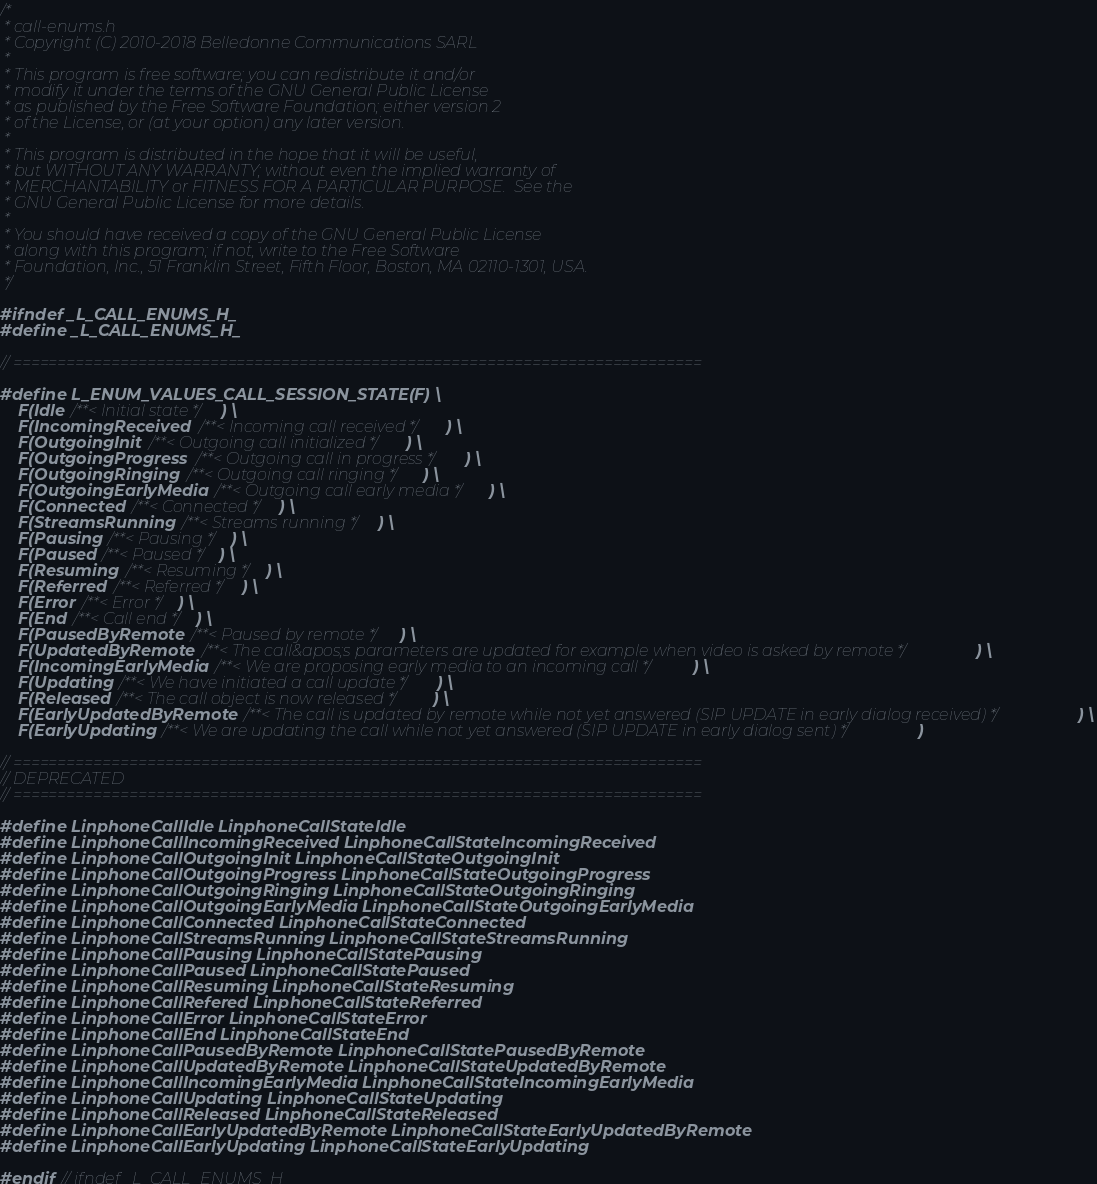Convert code to text. <code><loc_0><loc_0><loc_500><loc_500><_C_>/*
 * call-enums.h
 * Copyright (C) 2010-2018 Belledonne Communications SARL
 *
 * This program is free software; you can redistribute it and/or
 * modify it under the terms of the GNU General Public License
 * as published by the Free Software Foundation; either version 2
 * of the License, or (at your option) any later version.
 *
 * This program is distributed in the hope that it will be useful,
 * but WITHOUT ANY WARRANTY; without even the implied warranty of
 * MERCHANTABILITY or FITNESS FOR A PARTICULAR PURPOSE.  See the
 * GNU General Public License for more details.
 *
 * You should have received a copy of the GNU General Public License
 * along with this program; if not, write to the Free Software
 * Foundation, Inc., 51 Franklin Street, Fifth Floor, Boston, MA 02110-1301, USA.
 */

#ifndef _L_CALL_ENUMS_H_
#define _L_CALL_ENUMS_H_

// =============================================================================

#define L_ENUM_VALUES_CALL_SESSION_STATE(F) \
	F(Idle /**< Initial state */) \
	F(IncomingReceived /**< Incoming call received */) \
	F(OutgoingInit /**< Outgoing call initialized */) \
	F(OutgoingProgress /**< Outgoing call in progress */) \
	F(OutgoingRinging /**< Outgoing call ringing */) \
	F(OutgoingEarlyMedia /**< Outgoing call early media */) \
	F(Connected /**< Connected */) \
	F(StreamsRunning /**< Streams running */) \
	F(Pausing /**< Pausing */) \
	F(Paused /**< Paused */) \
	F(Resuming /**< Resuming */) \
	F(Referred /**< Referred */) \
	F(Error /**< Error */) \
	F(End /**< Call end */) \
	F(PausedByRemote /**< Paused by remote */) \
	F(UpdatedByRemote /**< The call&apos;s parameters are updated for example when video is asked by remote */) \
	F(IncomingEarlyMedia /**< We are proposing early media to an incoming call */) \
	F(Updating /**< We have initiated a call update */) \
	F(Released /**< The call object is now released */) \
	F(EarlyUpdatedByRemote /**< The call is updated by remote while not yet answered (SIP UPDATE in early dialog received) */) \
	F(EarlyUpdating /**< We are updating the call while not yet answered (SIP UPDATE in early dialog sent) */)

// =============================================================================
// DEPRECATED
// =============================================================================

#define LinphoneCallIdle LinphoneCallStateIdle
#define LinphoneCallIncomingReceived LinphoneCallStateIncomingReceived
#define LinphoneCallOutgoingInit LinphoneCallStateOutgoingInit
#define LinphoneCallOutgoingProgress LinphoneCallStateOutgoingProgress
#define LinphoneCallOutgoingRinging LinphoneCallStateOutgoingRinging
#define LinphoneCallOutgoingEarlyMedia LinphoneCallStateOutgoingEarlyMedia
#define LinphoneCallConnected LinphoneCallStateConnected
#define LinphoneCallStreamsRunning LinphoneCallStateStreamsRunning
#define LinphoneCallPausing LinphoneCallStatePausing
#define LinphoneCallPaused LinphoneCallStatePaused
#define LinphoneCallResuming LinphoneCallStateResuming
#define LinphoneCallRefered LinphoneCallStateReferred
#define LinphoneCallError LinphoneCallStateError
#define LinphoneCallEnd LinphoneCallStateEnd
#define LinphoneCallPausedByRemote LinphoneCallStatePausedByRemote
#define LinphoneCallUpdatedByRemote LinphoneCallStateUpdatedByRemote
#define LinphoneCallIncomingEarlyMedia LinphoneCallStateIncomingEarlyMedia
#define LinphoneCallUpdating LinphoneCallStateUpdating
#define LinphoneCallReleased LinphoneCallStateReleased
#define LinphoneCallEarlyUpdatedByRemote LinphoneCallStateEarlyUpdatedByRemote
#define LinphoneCallEarlyUpdating LinphoneCallStateEarlyUpdating

#endif // ifndef _L_CALL_ENUMS_H_
</code> 